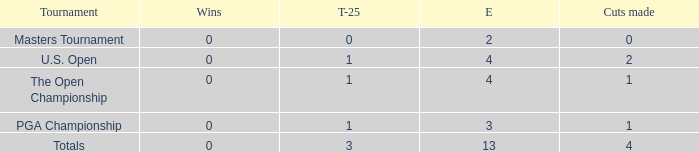How many cuts did he make in the tournament with 3 top 25s and under 13 events? None. Can you parse all the data within this table? {'header': ['Tournament', 'Wins', 'T-25', 'E', 'Cuts made'], 'rows': [['Masters Tournament', '0', '0', '2', '0'], ['U.S. Open', '0', '1', '4', '2'], ['The Open Championship', '0', '1', '4', '1'], ['PGA Championship', '0', '1', '3', '1'], ['Totals', '0', '3', '13', '4']]} 